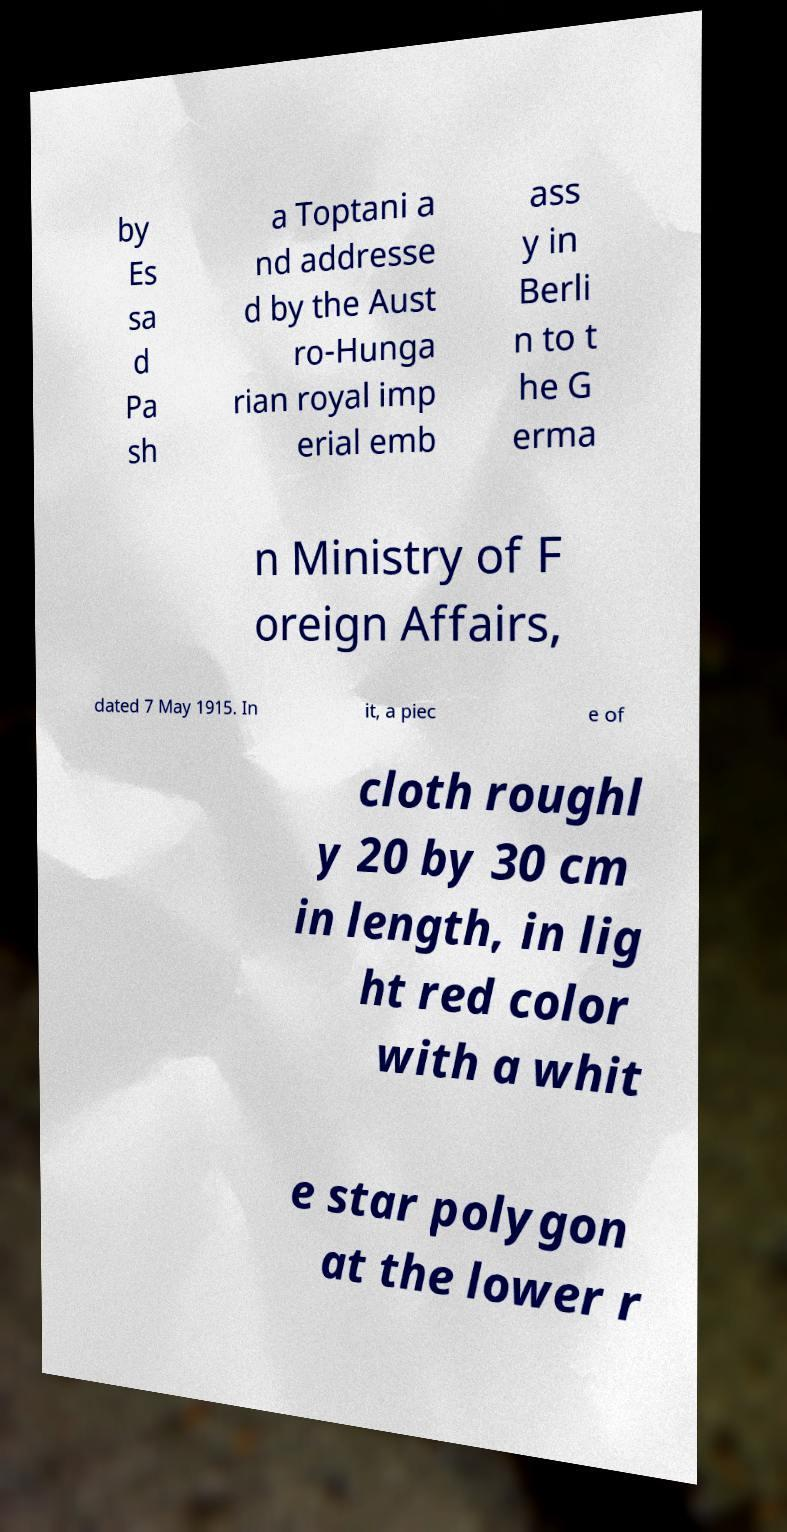Can you accurately transcribe the text from the provided image for me? by Es sa d Pa sh a Toptani a nd addresse d by the Aust ro-Hunga rian royal imp erial emb ass y in Berli n to t he G erma n Ministry of F oreign Affairs, dated 7 May 1915. In it, a piec e of cloth roughl y 20 by 30 cm in length, in lig ht red color with a whit e star polygon at the lower r 